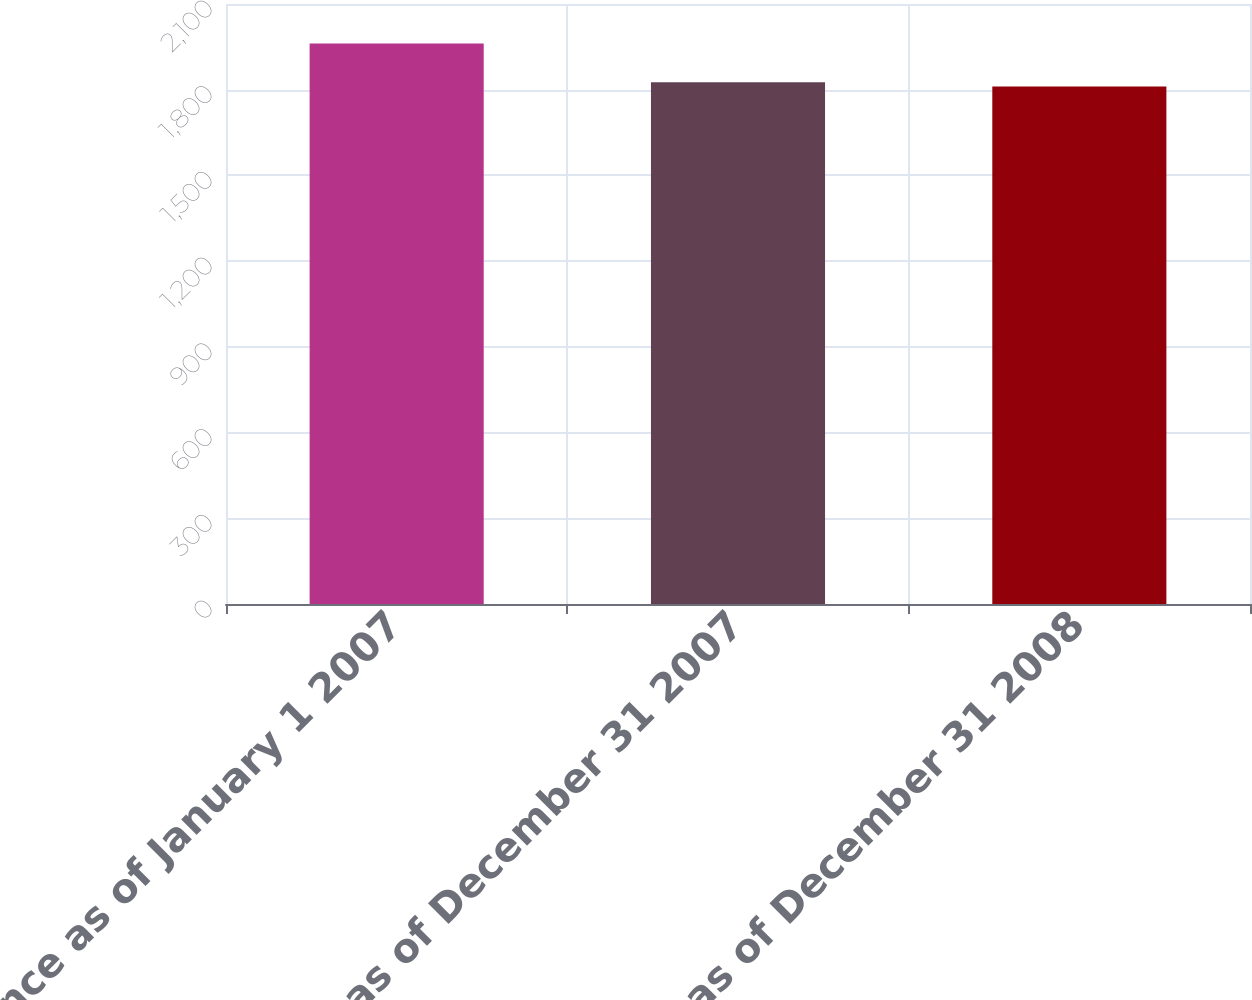<chart> <loc_0><loc_0><loc_500><loc_500><bar_chart><fcel>Balance as of January 1 2007<fcel>Balance as of December 31 2007<fcel>Balance as of December 31 2008<nl><fcel>1962<fcel>1826.1<fcel>1811<nl></chart> 